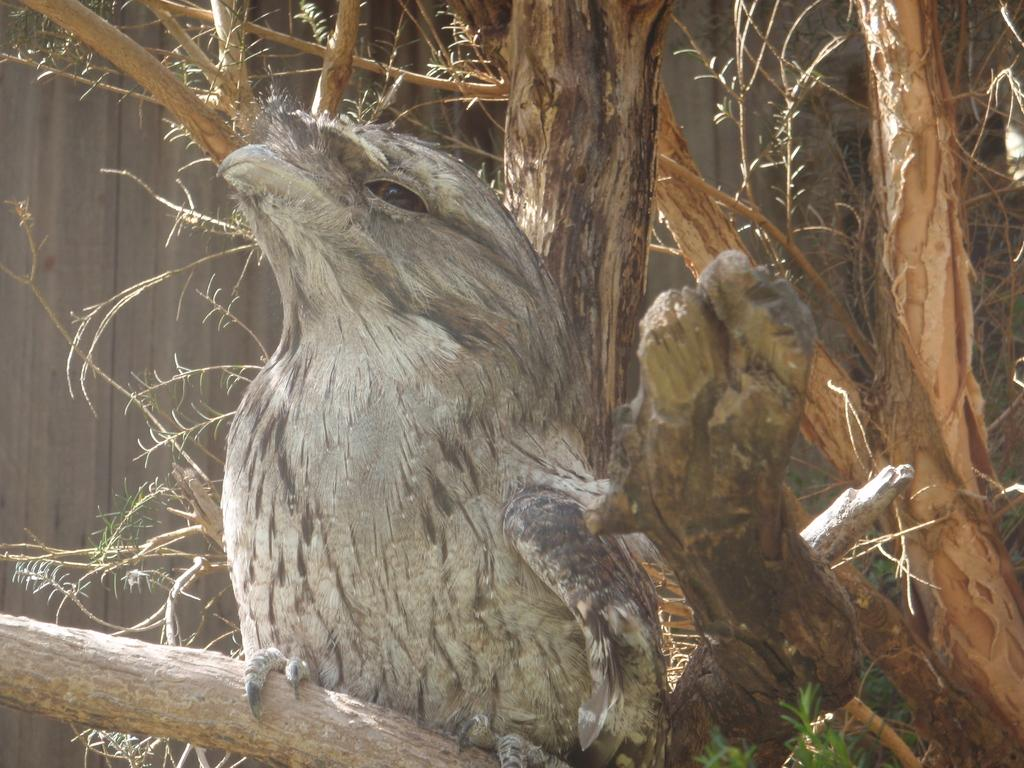What type of animal is present in the image? There is a bird in the image. What part of a tree can be seen in the image? There are trunks of a tree in the image. What type of vegetation is present in the image? There is a plant in the image. What type of beef is being served on a plate in the image? There is no beef or plate present in the image; it features a bird, tree trunks, and a plant. 